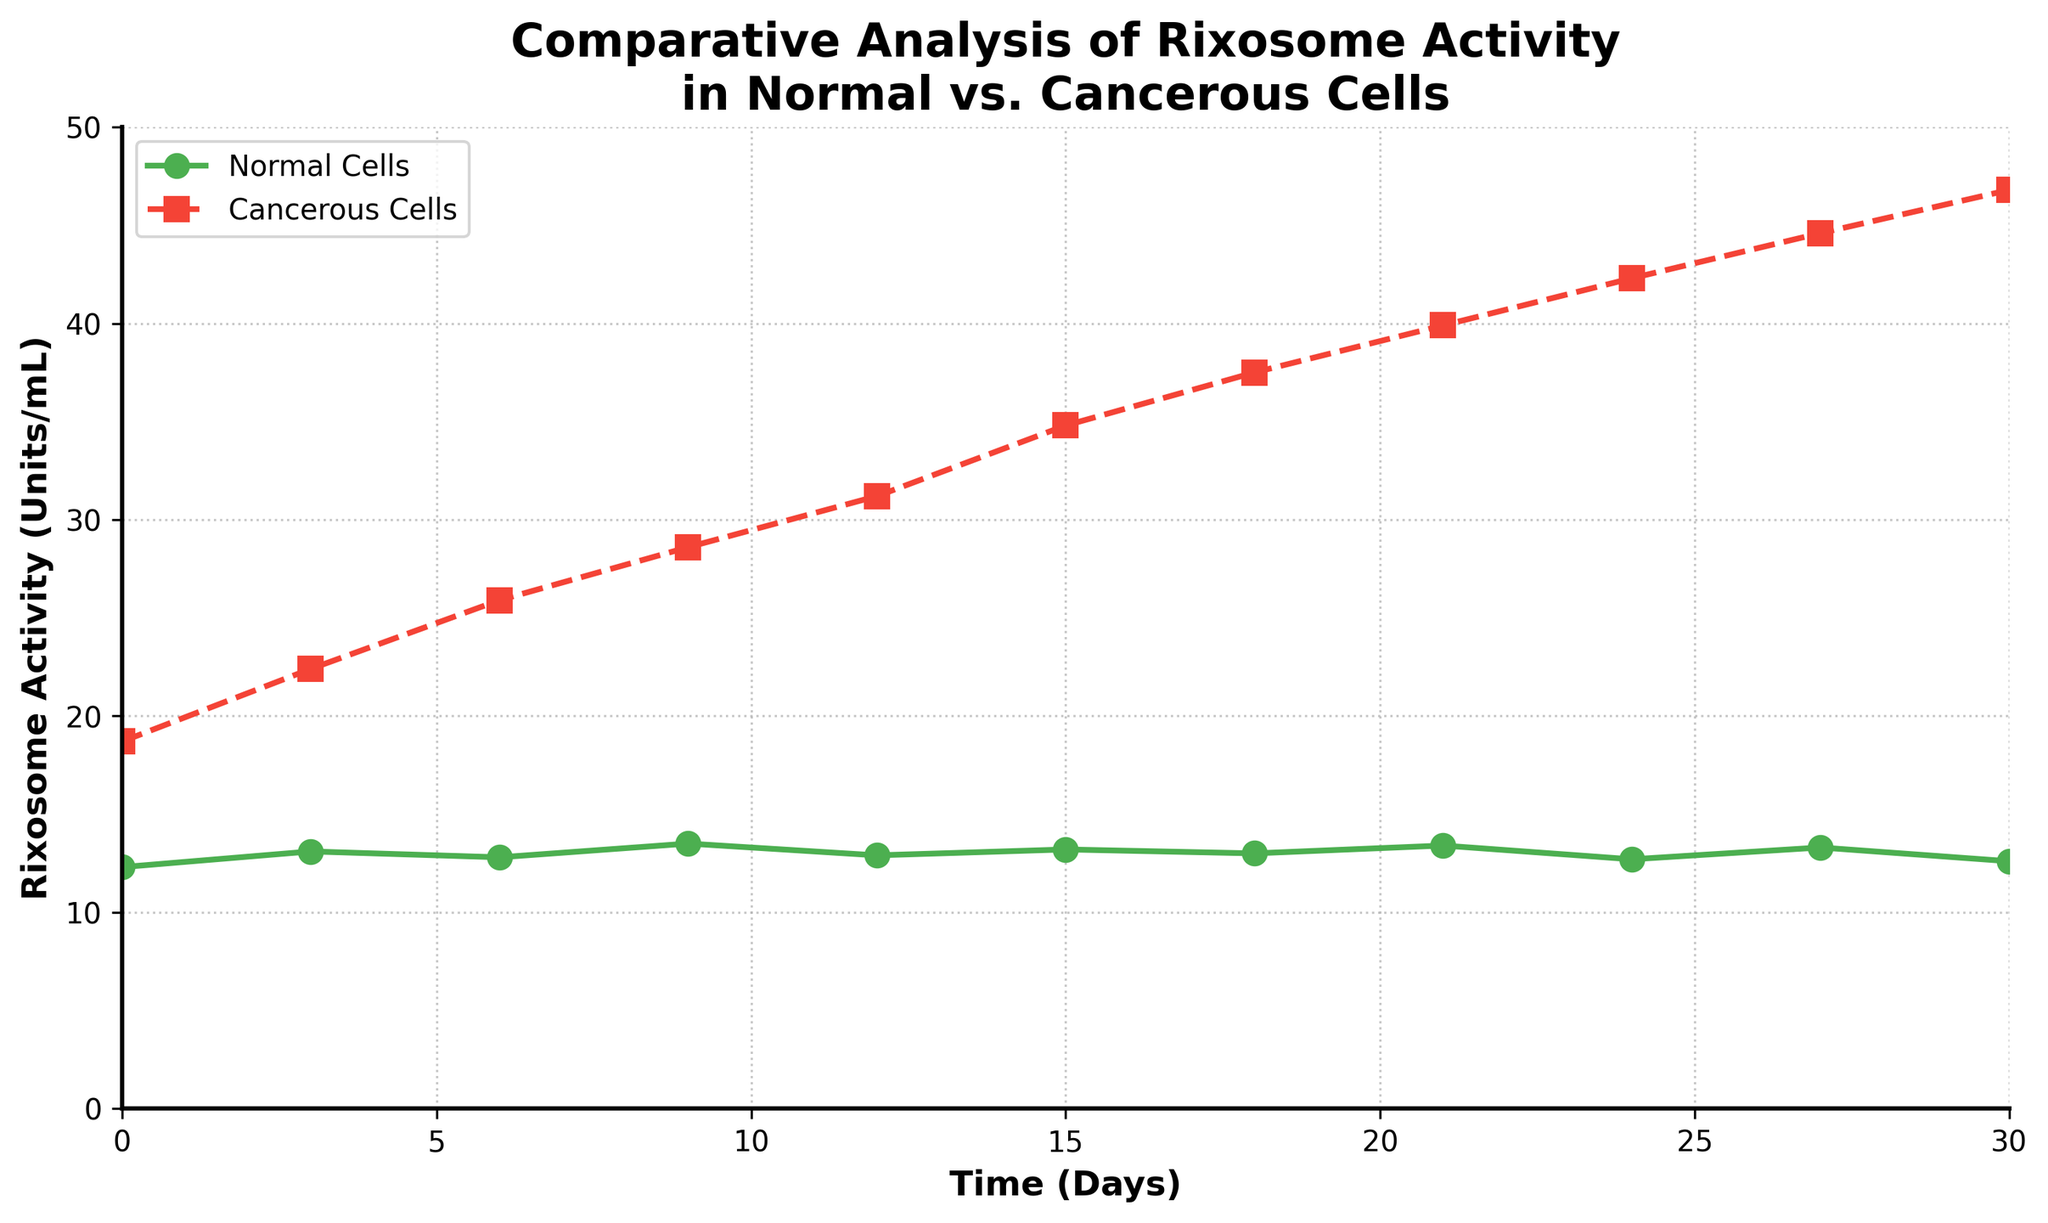What's the rixosome activity level in normal cells on Day 15? The plot shows the time on the x-axis and the rixosome activity level on the y-axis for both normal and cancerous cells. Looking at Day 15 for normal cells, we find the rixosome activity level.
Answer: 13.2 Units/mL What's the difference in rixosome activity between normal and cancerous cells on Day 9? On Day 9, the rixosome activity level for normal cells is 13.5 Units/mL, and for cancerous cells, it is 28.6 Units/mL. The difference is calculated as 28.6 - 13.5 = 15.1 Units/mL.
Answer: 15.1 Units/mL By how much does cancerous cell rixosome activity increase from Day 3 to Day 21? On Day 3, the cancerous cell activity is 22.4 Units/mL, and on Day 21, it is 39.9 Units/mL. The increase is calculated as 39.9 - 22.4 = 17.5 Units/mL.
Answer: 17.5 Units/mL Are there any time points where normal cell rixosome activity decreases compared to the previous time point? To determine this, we check each consecutive time point for normal cell rixosome activity. From the data: 13.1 (Day 3) > 12.3 (Day 0), 12.8 (Day 6) < 13.1 (Day 3), 13.5 (Day 9) > 12.8 (Day 6), etc. There is a decrease from Day 3 to Day 6, and another from Day 24 to Day 27.
Answer: Yes Compare the rixosome activity in normal cells on Day 6 with that in cancerous cells on the same day. Which one is greater? On Day 6, normal cell activity is 12.8 Units/mL, and cancerous cell activity is 25.9 Units/mL. Comparing the two, 25.9 > 12.8.
Answer: Cancerous cells What is the average rixosome activity level in cancerous cells over the treatment period? To find the average, sum all cancerous cell rixosome activity levels and divide by the number of points. (18.7 + 22.4 + 25.9 + 28.6 + 31.2 + 34.8 + 37.5 + 39.9 + 42.3 + 44.6 + 46.8) / 11 = 35.66 (rounded to two decimal places).
Answer: 35.66 Units/mL What is the trend of rixosome activity in cancerous cells over the 30-day period? Observing the cancerous cell activity trend from the plot, it increases continuously from Day 0 to Day 30, indicating a positive growth trend.
Answer: Increasing For which days does the rixosome activity in normal cells fall below 13 Units/mL? Checking the plot for normal cell rixosome levels below 13 Units/mL, Days 0 (12.3), 6 (12.8), 12 (12.9), 18 (13.0), 24 (12.7), and 30 (12.6) fit this criterion.
Answer: Days 0, 6, 12, 24, 30 How much does normal cell rixosome activity fluctuate over the 30-day period? Fluctuation range is determined by the difference between the maximum and minimum values of normal cell rixosome activity. Max = 13.5 Units/mL (Day 9), Min = 12.3 Units/mL (Day 0). The fluctuation is 13.5 - 12.3 = 1.2 Units/mL.
Answer: 1.2 Units/mL 